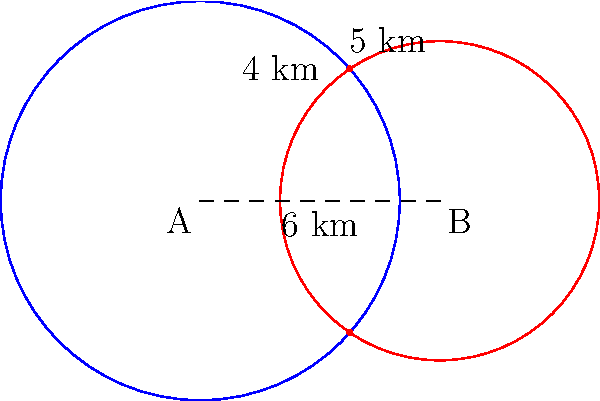In a naval anti-piracy operation, two sonar systems are deployed 6 km apart. System A has a detection range of 5 km, while System B has a range of 4 km. How many intersection points are there between the two detection ranges, and what is the distance between these points? To solve this problem, we'll follow these steps:

1) First, we need to determine if the circles intersect. They will intersect if the distance between their centers is less than the sum of their radii but greater than the absolute difference of their radii.

   $6 < 5 + 4 = 9$ and $6 > |5 - 4| = 1$, so they do intersect.

2) Since they intersect, there are two intersection points.

3) To find the distance between these points, we can use the formula for the distance between intersection points of two circles:

   $d = 2\sqrt{\frac{(r_1+r_2)^2-c^2}{4}\cdot\frac{c^2-(r_1-r_2)^2}{4}}$

   Where $r_1$ and $r_2$ are the radii of the circles and $c$ is the distance between their centers.

4) Plugging in our values:
   $r_1 = 5$, $r_2 = 4$, $c = 6$

   $d = 2\sqrt{\frac{(5+4)^2-6^2}{4}\cdot\frac{6^2-(5-4)^2}{4}}$

5) Simplifying:
   $d = 2\sqrt{\frac{81-36}{4}\cdot\frac{36-1}{4}}$
   $d = 2\sqrt{\frac{45}{4}\cdot\frac{35}{4}}$
   $d = 2\sqrt{\frac{1575}{16}}$
   $d = 2\cdot\frac{\sqrt{1575}}{4}$
   $d = \frac{\sqrt{1575}}{2} \approx 6.26$ km

Therefore, there are 2 intersection points, and the distance between them is approximately 6.26 km.
Answer: 2 intersection points; $\frac{\sqrt{1575}}{2}$ km apart 